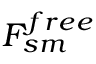Convert formula to latex. <formula><loc_0><loc_0><loc_500><loc_500>F _ { s m } ^ { f r e e }</formula> 